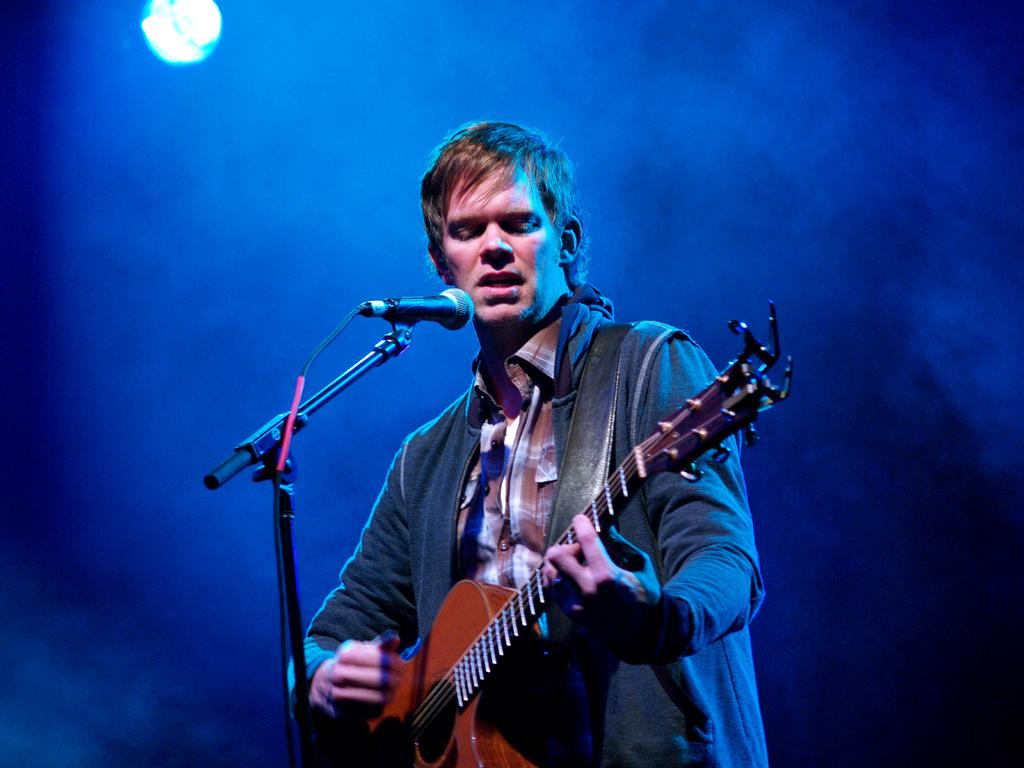Who is the main subject in the image? There is a person in the image. What is the person wearing? The person is wearing a jacket. What is the person holding? The person is holding a guitar. What is the person doing with the guitar? The person is playing the guitar. What is the person standing in front of? The person is standing in front of a microphone. What type of spark can be seen coming from the guitar in the image? There is no spark visible in the image; the person is simply playing the guitar. 